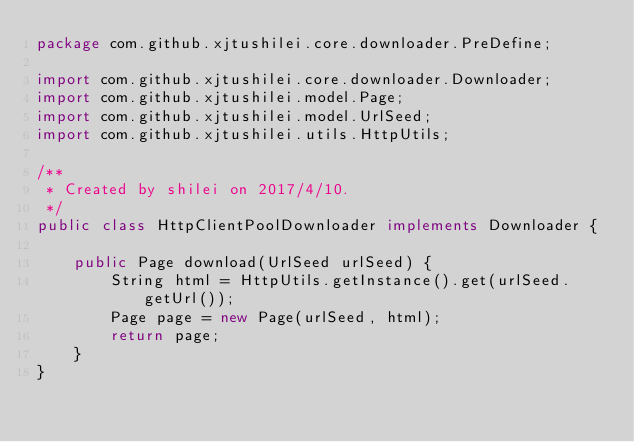<code> <loc_0><loc_0><loc_500><loc_500><_Java_>package com.github.xjtushilei.core.downloader.PreDefine;

import com.github.xjtushilei.core.downloader.Downloader;
import com.github.xjtushilei.model.Page;
import com.github.xjtushilei.model.UrlSeed;
import com.github.xjtushilei.utils.HttpUtils;

/**
 * Created by shilei on 2017/4/10.
 */
public class HttpClientPoolDownloader implements Downloader {

    public Page download(UrlSeed urlSeed) {
        String html = HttpUtils.getInstance().get(urlSeed.getUrl());
        Page page = new Page(urlSeed, html);
        return page;
    }
}
</code> 